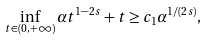<formula> <loc_0><loc_0><loc_500><loc_500>\inf _ { t \in ( 0 , + \infty ) } \alpha t ^ { 1 - 2 s } + t \geq c _ { 1 } \alpha ^ { 1 / ( 2 s ) } ,</formula> 